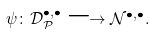Convert formula to latex. <formula><loc_0><loc_0><loc_500><loc_500>\psi \colon { \mathcal { D } } _ { \mathcal { P } } ^ { \bullet , \bullet } \longrightarrow { \mathcal { N } } ^ { \bullet , \bullet } .</formula> 